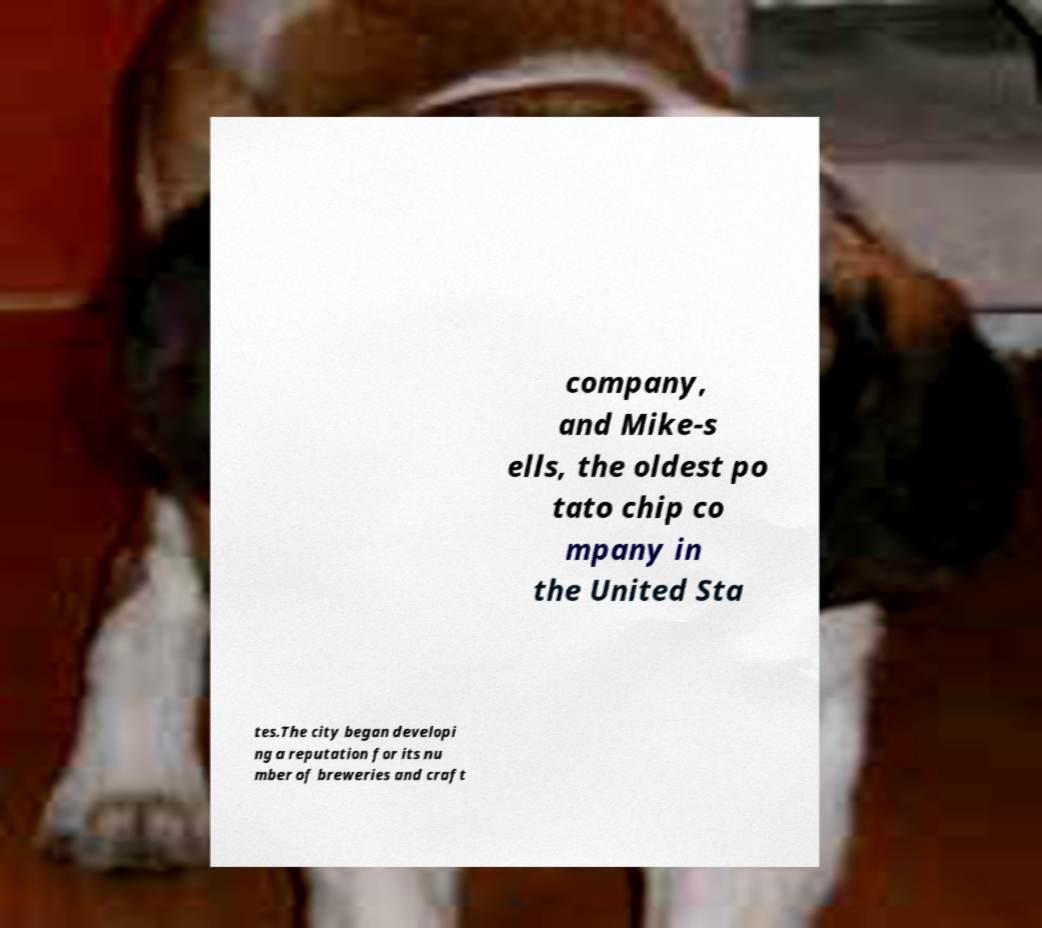Please identify and transcribe the text found in this image. company, and Mike-s ells, the oldest po tato chip co mpany in the United Sta tes.The city began developi ng a reputation for its nu mber of breweries and craft 